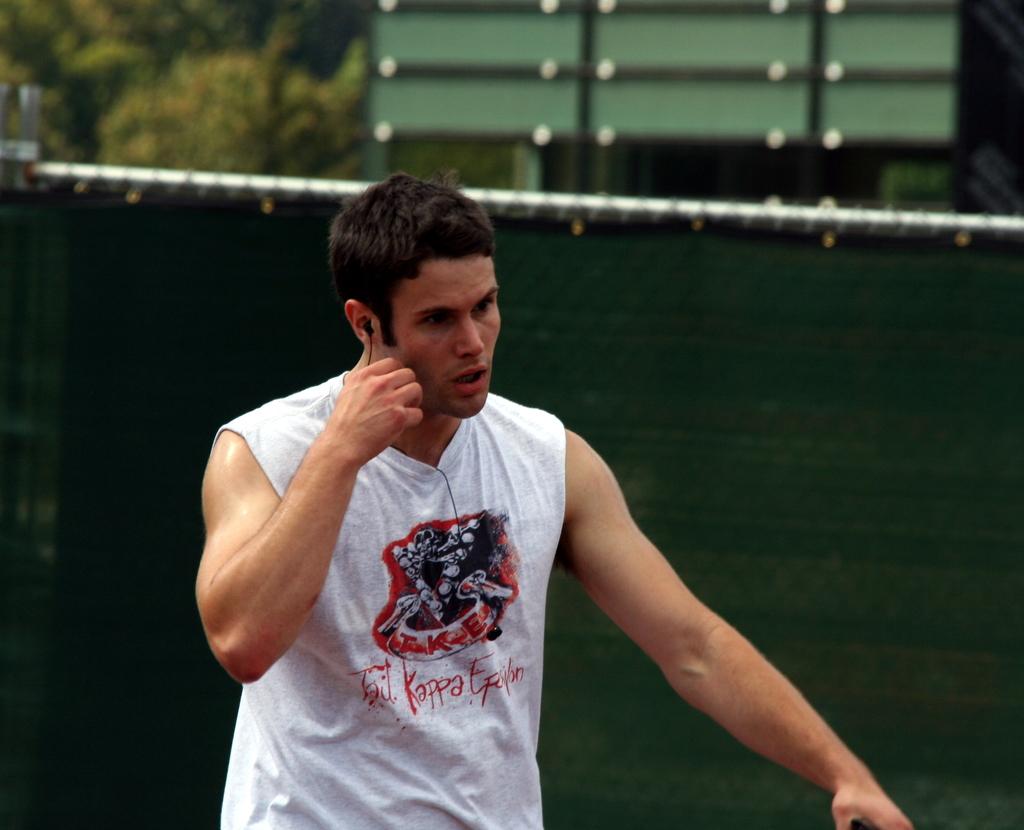Which fraternity does he belong to?
Provide a short and direct response. Tau kappa epsilon. 